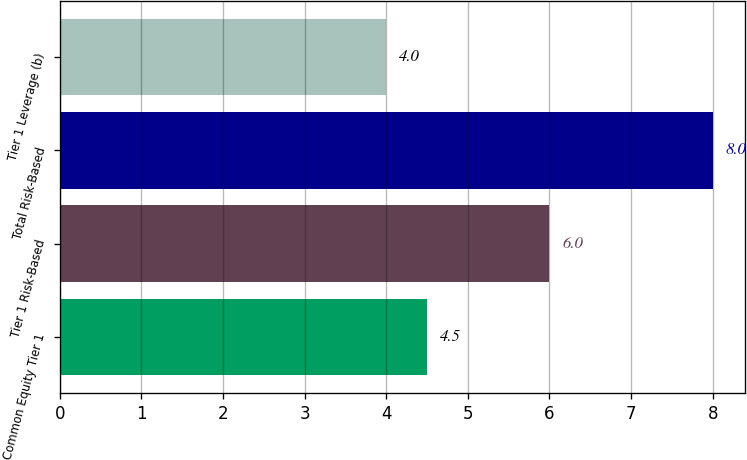Convert chart. <chart><loc_0><loc_0><loc_500><loc_500><bar_chart><fcel>Common Equity Tier 1<fcel>Tier 1 Risk-Based<fcel>Total Risk-Based<fcel>Tier 1 Leverage (b)<nl><fcel>4.5<fcel>6<fcel>8<fcel>4<nl></chart> 